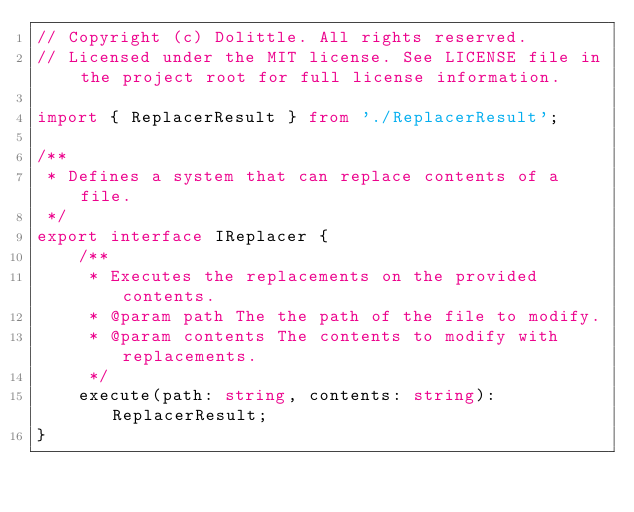<code> <loc_0><loc_0><loc_500><loc_500><_TypeScript_>// Copyright (c) Dolittle. All rights reserved.
// Licensed under the MIT license. See LICENSE file in the project root for full license information.

import { ReplacerResult } from './ReplacerResult';

/**
 * Defines a system that can replace contents of a file.
 */
export interface IReplacer {
    /**
     * Executes the replacements on the provided contents.
     * @param path The the path of the file to modify.
     * @param contents The contents to modify with replacements.
     */
    execute(path: string, contents: string): ReplacerResult;
}
</code> 